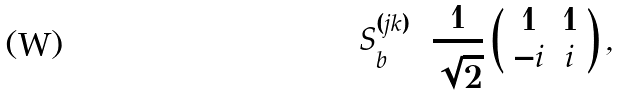Convert formula to latex. <formula><loc_0><loc_0><loc_500><loc_500>S _ { b } ^ { ( j k ) } = \frac { 1 } { \sqrt { 2 } } \left ( \begin{array} { c c c c } 1 & 1 \\ - i & i \end{array} \right ) ,</formula> 